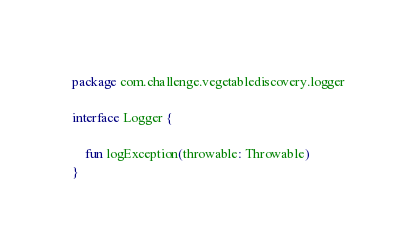Convert code to text. <code><loc_0><loc_0><loc_500><loc_500><_Kotlin_>package com.challenge.vegetablediscovery.logger

interface Logger {

    fun logException(throwable: Throwable)
}</code> 